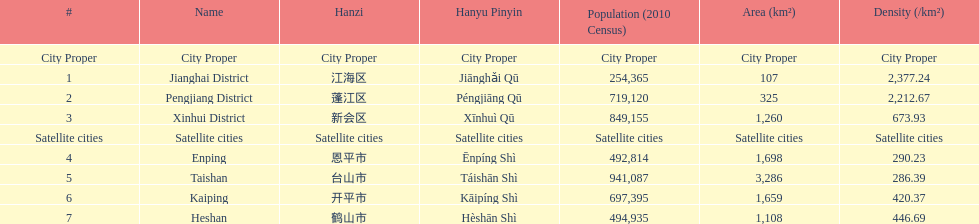What is the difference in population between enping and heshan? 2121. I'm looking to parse the entire table for insights. Could you assist me with that? {'header': ['#', 'Name', 'Hanzi', 'Hanyu Pinyin', 'Population (2010 Census)', 'Area (km²)', 'Density (/km²)'], 'rows': [['City Proper', 'City Proper', 'City Proper', 'City Proper', 'City Proper', 'City Proper', 'City Proper'], ['1', 'Jianghai District', '江海区', 'Jiānghǎi Qū', '254,365', '107', '2,377.24'], ['2', 'Pengjiang District', '蓬江区', 'Péngjiāng Qū', '719,120', '325', '2,212.67'], ['3', 'Xinhui District', '新会区', 'Xīnhuì Qū', '849,155', '1,260', '673.93'], ['Satellite cities', 'Satellite cities', 'Satellite cities', 'Satellite cities', 'Satellite cities', 'Satellite cities', 'Satellite cities'], ['4', 'Enping', '恩平市', 'Ēnpíng Shì', '492,814', '1,698', '290.23'], ['5', 'Taishan', '台山市', 'Táishān Shì', '941,087', '3,286', '286.39'], ['6', 'Kaiping', '开平市', 'Kāipíng Shì', '697,395', '1,659', '420.37'], ['7', 'Heshan', '鹤山市', 'Hèshān Shì', '494,935', '1,108', '446.69']]} 